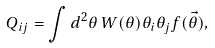Convert formula to latex. <formula><loc_0><loc_0><loc_500><loc_500>Q _ { i j } = \int d ^ { 2 } \theta \, W ( \theta ) \theta _ { i } \theta _ { j } f ( \vec { \theta } ) ,</formula> 